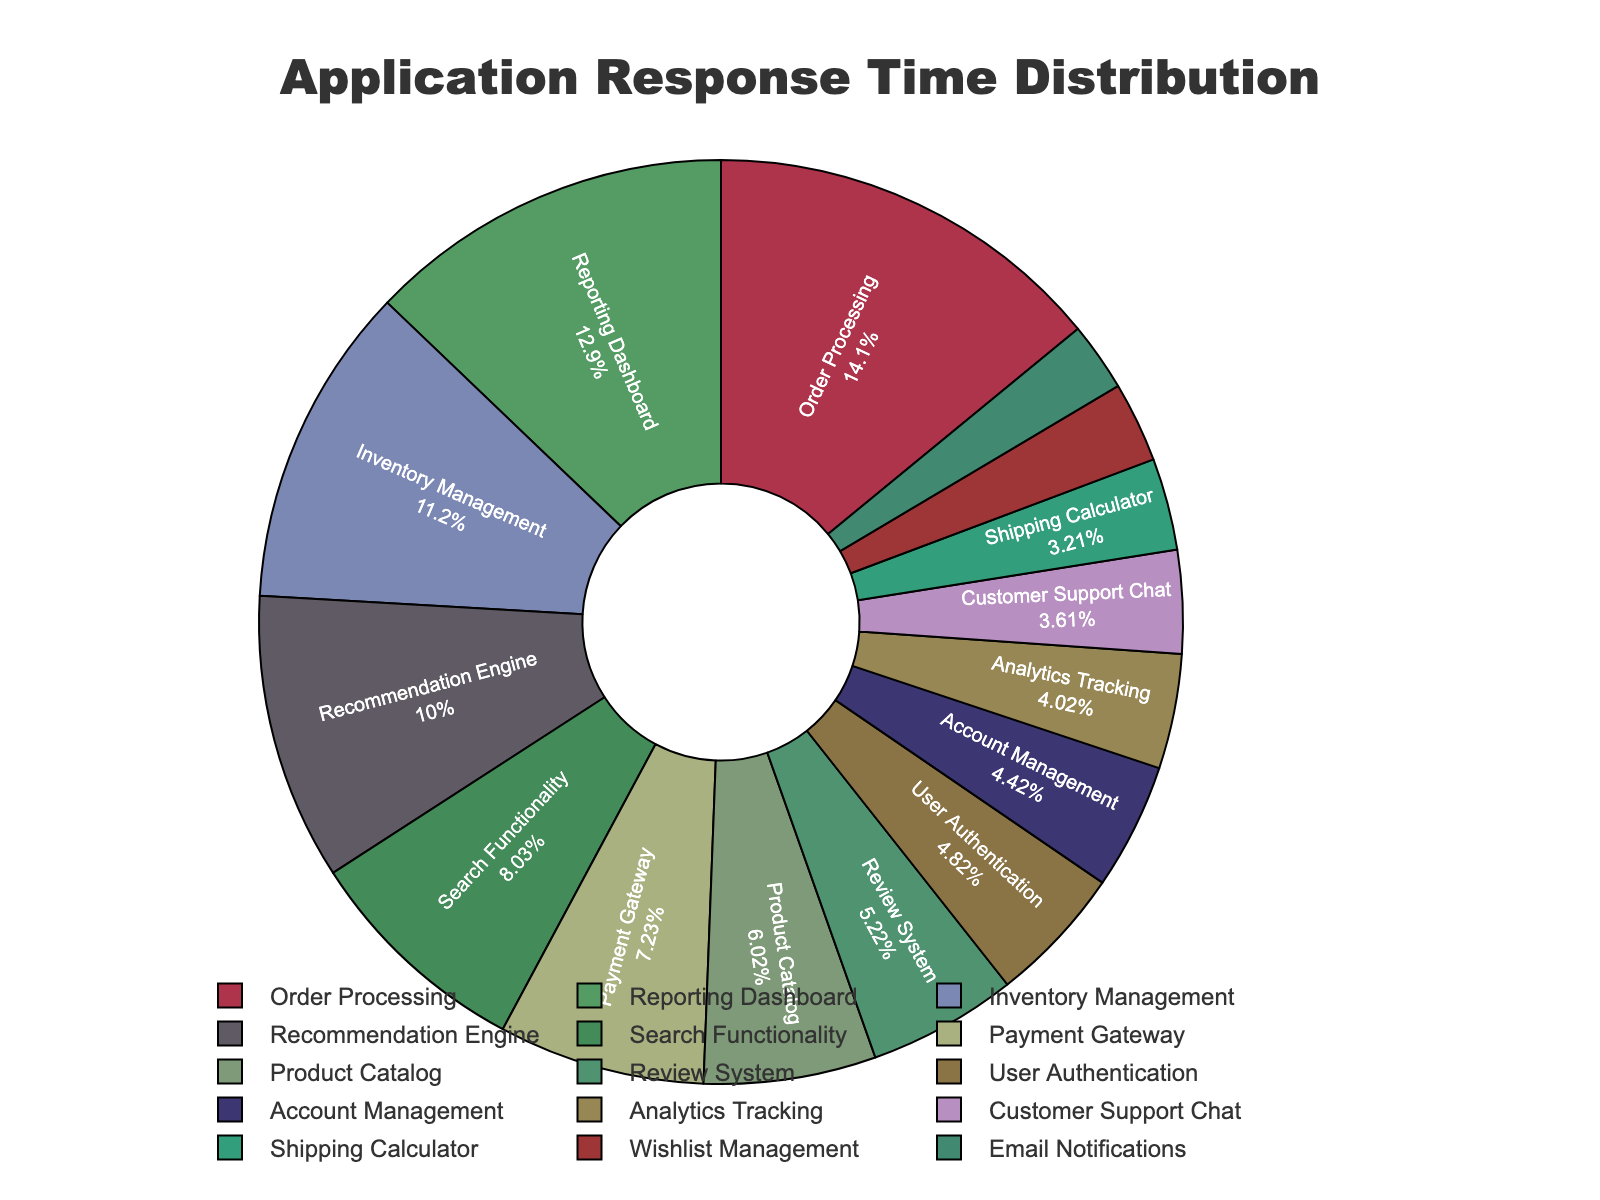What's the percentage contribution of the Order Processing module to the total response time? Find the slice labeled "Order Processing" on the pie chart and note the percentage indicated.
Answer: 21.59% Which module has the smallest percentage of total response time? Identify the smallest slice in the pie chart and note the label.
Answer: Email Notifications Compare the response times of Payment Gateway and Search Functionality modules. Which one is higher? Look at the slices labeled "Payment Gateway" and "Search Functionality", and compare their percentages.
Answer: Search Functionality What is the combined percentage contribution of the Reporting Dashboard and Inventory Management modules? Add the percentages of the slices labeled "Reporting Dashboard" and "Inventory Management".
Answer: 19.26% Is the response time of the User Authentication module greater than that of the Product Catalog? Compare the size of the slices for "User Authentication" and "Product Catalog". The larger slice will have the greater percentage.
Answer: Yes Which three modules have the highest response times, and what are their combined percentages? Identify the three largest slices, note their labels and add their percentages.
Answer: Order Processing, Reporting Dashboard, Inventory Management; 49.19% Compare the response times of Recommendation Engine and Customer Support Chat. Which one has a higher response time and by how much? Identify the slices for "Recommendation Engine" and "Customer Support Chat", compare their percentages, then calculate the difference.
Answer: Recommendation Engine; 6.64% How does the response time percentage of the Analytics Tracking module compare to that of the Wishlist Management module? Compare the percentages of the slices labeled "Analytics Tracking" and "Wishlist Management".
Answer: Higher 